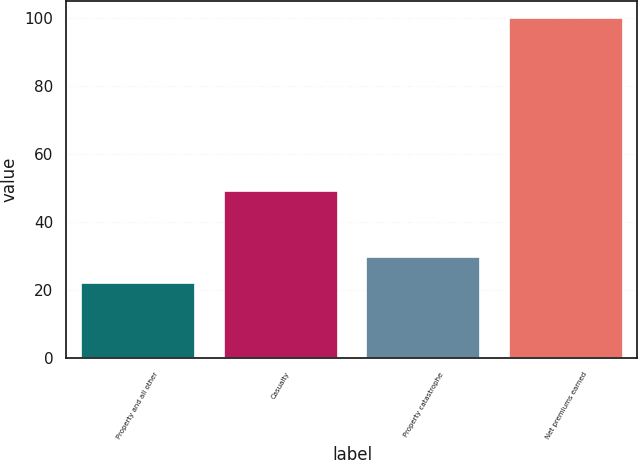Convert chart to OTSL. <chart><loc_0><loc_0><loc_500><loc_500><bar_chart><fcel>Property and all other<fcel>Casualty<fcel>Property catastrophe<fcel>Net premiums earned<nl><fcel>22<fcel>49<fcel>29.8<fcel>100<nl></chart> 